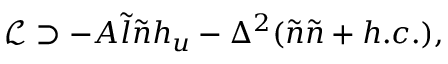Convert formula to latex. <formula><loc_0><loc_0><loc_500><loc_500>\mathcal { L } \supset - A \tilde { l } \tilde { n } h _ { u } - \Delta ^ { 2 } ( \tilde { n } \tilde { n } + h . c . ) ,</formula> 